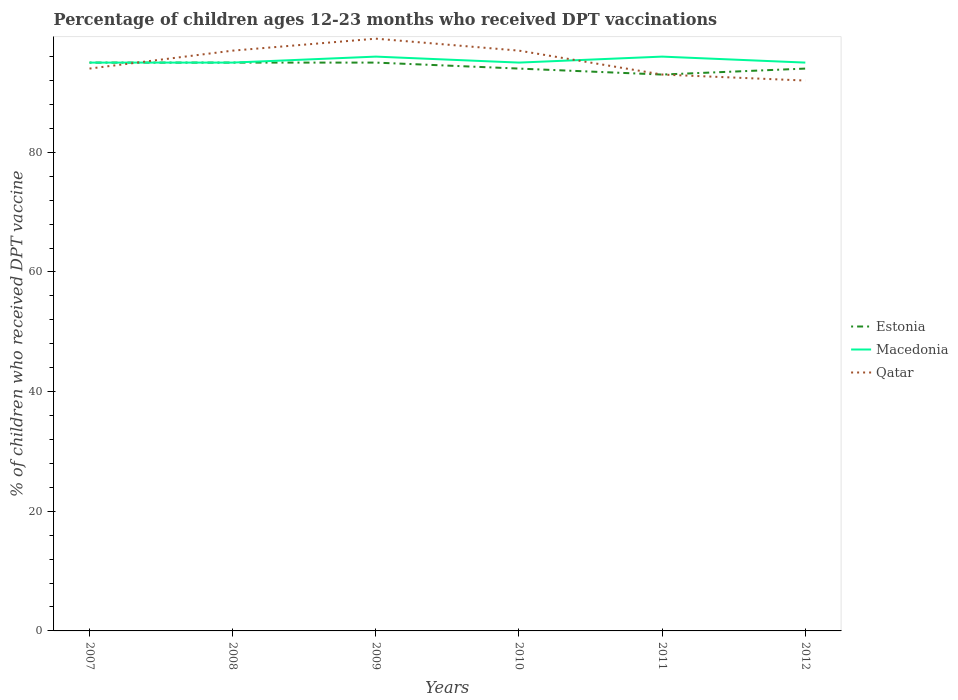How many different coloured lines are there?
Ensure brevity in your answer.  3. Does the line corresponding to Macedonia intersect with the line corresponding to Qatar?
Ensure brevity in your answer.  Yes. Is the number of lines equal to the number of legend labels?
Provide a short and direct response. Yes. Across all years, what is the maximum percentage of children who received DPT vaccination in Qatar?
Give a very brief answer. 92. What is the difference between the highest and the second highest percentage of children who received DPT vaccination in Estonia?
Give a very brief answer. 2. Is the percentage of children who received DPT vaccination in Estonia strictly greater than the percentage of children who received DPT vaccination in Qatar over the years?
Provide a succinct answer. No. What is the difference between two consecutive major ticks on the Y-axis?
Offer a terse response. 20. Are the values on the major ticks of Y-axis written in scientific E-notation?
Keep it short and to the point. No. Does the graph contain grids?
Keep it short and to the point. No. How many legend labels are there?
Your answer should be very brief. 3. How are the legend labels stacked?
Offer a very short reply. Vertical. What is the title of the graph?
Your response must be concise. Percentage of children ages 12-23 months who received DPT vaccinations. Does "Turks and Caicos Islands" appear as one of the legend labels in the graph?
Offer a terse response. No. What is the label or title of the Y-axis?
Ensure brevity in your answer.  % of children who received DPT vaccine. What is the % of children who received DPT vaccine in Macedonia in 2007?
Your answer should be very brief. 95. What is the % of children who received DPT vaccine of Qatar in 2007?
Your answer should be very brief. 94. What is the % of children who received DPT vaccine in Estonia in 2008?
Provide a short and direct response. 95. What is the % of children who received DPT vaccine in Qatar in 2008?
Your response must be concise. 97. What is the % of children who received DPT vaccine in Macedonia in 2009?
Offer a terse response. 96. What is the % of children who received DPT vaccine in Qatar in 2009?
Offer a terse response. 99. What is the % of children who received DPT vaccine in Estonia in 2010?
Your response must be concise. 94. What is the % of children who received DPT vaccine of Macedonia in 2010?
Ensure brevity in your answer.  95. What is the % of children who received DPT vaccine of Qatar in 2010?
Your response must be concise. 97. What is the % of children who received DPT vaccine of Estonia in 2011?
Ensure brevity in your answer.  93. What is the % of children who received DPT vaccine in Macedonia in 2011?
Offer a terse response. 96. What is the % of children who received DPT vaccine in Qatar in 2011?
Provide a short and direct response. 93. What is the % of children who received DPT vaccine of Estonia in 2012?
Ensure brevity in your answer.  94. What is the % of children who received DPT vaccine in Qatar in 2012?
Give a very brief answer. 92. Across all years, what is the maximum % of children who received DPT vaccine in Estonia?
Offer a very short reply. 95. Across all years, what is the maximum % of children who received DPT vaccine in Macedonia?
Your response must be concise. 96. Across all years, what is the minimum % of children who received DPT vaccine of Estonia?
Your answer should be compact. 93. Across all years, what is the minimum % of children who received DPT vaccine of Macedonia?
Keep it short and to the point. 95. Across all years, what is the minimum % of children who received DPT vaccine in Qatar?
Your response must be concise. 92. What is the total % of children who received DPT vaccine of Estonia in the graph?
Provide a succinct answer. 566. What is the total % of children who received DPT vaccine in Macedonia in the graph?
Make the answer very short. 572. What is the total % of children who received DPT vaccine in Qatar in the graph?
Offer a very short reply. 572. What is the difference between the % of children who received DPT vaccine of Estonia in 2007 and that in 2008?
Your answer should be compact. 0. What is the difference between the % of children who received DPT vaccine of Macedonia in 2007 and that in 2008?
Offer a very short reply. 0. What is the difference between the % of children who received DPT vaccine in Qatar in 2007 and that in 2008?
Your response must be concise. -3. What is the difference between the % of children who received DPT vaccine in Estonia in 2007 and that in 2009?
Keep it short and to the point. 0. What is the difference between the % of children who received DPT vaccine of Macedonia in 2007 and that in 2009?
Give a very brief answer. -1. What is the difference between the % of children who received DPT vaccine of Macedonia in 2007 and that in 2010?
Offer a very short reply. 0. What is the difference between the % of children who received DPT vaccine of Qatar in 2007 and that in 2010?
Offer a very short reply. -3. What is the difference between the % of children who received DPT vaccine in Macedonia in 2007 and that in 2011?
Provide a short and direct response. -1. What is the difference between the % of children who received DPT vaccine of Qatar in 2007 and that in 2012?
Keep it short and to the point. 2. What is the difference between the % of children who received DPT vaccine of Macedonia in 2008 and that in 2009?
Your response must be concise. -1. What is the difference between the % of children who received DPT vaccine of Qatar in 2008 and that in 2009?
Make the answer very short. -2. What is the difference between the % of children who received DPT vaccine in Macedonia in 2008 and that in 2010?
Provide a succinct answer. 0. What is the difference between the % of children who received DPT vaccine of Qatar in 2008 and that in 2011?
Your response must be concise. 4. What is the difference between the % of children who received DPT vaccine in Estonia in 2008 and that in 2012?
Ensure brevity in your answer.  1. What is the difference between the % of children who received DPT vaccine in Qatar in 2009 and that in 2011?
Give a very brief answer. 6. What is the difference between the % of children who received DPT vaccine in Macedonia in 2010 and that in 2011?
Your answer should be very brief. -1. What is the difference between the % of children who received DPT vaccine in Qatar in 2010 and that in 2011?
Offer a very short reply. 4. What is the difference between the % of children who received DPT vaccine in Estonia in 2010 and that in 2012?
Keep it short and to the point. 0. What is the difference between the % of children who received DPT vaccine in Macedonia in 2010 and that in 2012?
Ensure brevity in your answer.  0. What is the difference between the % of children who received DPT vaccine in Estonia in 2011 and that in 2012?
Provide a succinct answer. -1. What is the difference between the % of children who received DPT vaccine in Macedonia in 2011 and that in 2012?
Provide a short and direct response. 1. What is the difference between the % of children who received DPT vaccine of Estonia in 2007 and the % of children who received DPT vaccine of Macedonia in 2009?
Give a very brief answer. -1. What is the difference between the % of children who received DPT vaccine in Estonia in 2007 and the % of children who received DPT vaccine in Qatar in 2010?
Offer a very short reply. -2. What is the difference between the % of children who received DPT vaccine of Macedonia in 2007 and the % of children who received DPT vaccine of Qatar in 2010?
Keep it short and to the point. -2. What is the difference between the % of children who received DPT vaccine of Estonia in 2007 and the % of children who received DPT vaccine of Macedonia in 2012?
Your answer should be compact. 0. What is the difference between the % of children who received DPT vaccine in Estonia in 2007 and the % of children who received DPT vaccine in Qatar in 2012?
Your answer should be compact. 3. What is the difference between the % of children who received DPT vaccine in Macedonia in 2007 and the % of children who received DPT vaccine in Qatar in 2012?
Offer a very short reply. 3. What is the difference between the % of children who received DPT vaccine in Estonia in 2008 and the % of children who received DPT vaccine in Qatar in 2009?
Provide a succinct answer. -4. What is the difference between the % of children who received DPT vaccine of Estonia in 2008 and the % of children who received DPT vaccine of Macedonia in 2010?
Your answer should be very brief. 0. What is the difference between the % of children who received DPT vaccine in Estonia in 2008 and the % of children who received DPT vaccine in Qatar in 2010?
Offer a very short reply. -2. What is the difference between the % of children who received DPT vaccine of Macedonia in 2008 and the % of children who received DPT vaccine of Qatar in 2010?
Keep it short and to the point. -2. What is the difference between the % of children who received DPT vaccine in Estonia in 2008 and the % of children who received DPT vaccine in Macedonia in 2011?
Ensure brevity in your answer.  -1. What is the difference between the % of children who received DPT vaccine in Estonia in 2008 and the % of children who received DPT vaccine in Qatar in 2011?
Give a very brief answer. 2. What is the difference between the % of children who received DPT vaccine of Macedonia in 2008 and the % of children who received DPT vaccine of Qatar in 2011?
Your answer should be very brief. 2. What is the difference between the % of children who received DPT vaccine in Estonia in 2009 and the % of children who received DPT vaccine in Qatar in 2010?
Offer a terse response. -2. What is the difference between the % of children who received DPT vaccine of Estonia in 2009 and the % of children who received DPT vaccine of Macedonia in 2011?
Your answer should be very brief. -1. What is the difference between the % of children who received DPT vaccine of Estonia in 2009 and the % of children who received DPT vaccine of Qatar in 2011?
Give a very brief answer. 2. What is the difference between the % of children who received DPT vaccine of Macedonia in 2009 and the % of children who received DPT vaccine of Qatar in 2011?
Offer a very short reply. 3. What is the difference between the % of children who received DPT vaccine of Estonia in 2009 and the % of children who received DPT vaccine of Qatar in 2012?
Provide a succinct answer. 3. What is the difference between the % of children who received DPT vaccine of Estonia in 2010 and the % of children who received DPT vaccine of Macedonia in 2011?
Offer a very short reply. -2. What is the difference between the % of children who received DPT vaccine of Estonia in 2010 and the % of children who received DPT vaccine of Qatar in 2011?
Give a very brief answer. 1. What is the difference between the % of children who received DPT vaccine of Macedonia in 2010 and the % of children who received DPT vaccine of Qatar in 2011?
Provide a succinct answer. 2. What is the difference between the % of children who received DPT vaccine of Estonia in 2010 and the % of children who received DPT vaccine of Macedonia in 2012?
Your answer should be compact. -1. What is the difference between the % of children who received DPT vaccine in Estonia in 2010 and the % of children who received DPT vaccine in Qatar in 2012?
Your answer should be very brief. 2. What is the difference between the % of children who received DPT vaccine in Estonia in 2011 and the % of children who received DPT vaccine in Macedonia in 2012?
Give a very brief answer. -2. What is the average % of children who received DPT vaccine of Estonia per year?
Your response must be concise. 94.33. What is the average % of children who received DPT vaccine in Macedonia per year?
Offer a terse response. 95.33. What is the average % of children who received DPT vaccine of Qatar per year?
Your answer should be compact. 95.33. In the year 2007, what is the difference between the % of children who received DPT vaccine of Estonia and % of children who received DPT vaccine of Macedonia?
Offer a very short reply. 0. In the year 2007, what is the difference between the % of children who received DPT vaccine in Estonia and % of children who received DPT vaccine in Qatar?
Make the answer very short. 1. In the year 2007, what is the difference between the % of children who received DPT vaccine of Macedonia and % of children who received DPT vaccine of Qatar?
Provide a short and direct response. 1. In the year 2008, what is the difference between the % of children who received DPT vaccine of Estonia and % of children who received DPT vaccine of Macedonia?
Provide a short and direct response. 0. In the year 2008, what is the difference between the % of children who received DPT vaccine of Estonia and % of children who received DPT vaccine of Qatar?
Provide a short and direct response. -2. In the year 2008, what is the difference between the % of children who received DPT vaccine in Macedonia and % of children who received DPT vaccine in Qatar?
Offer a terse response. -2. In the year 2009, what is the difference between the % of children who received DPT vaccine in Estonia and % of children who received DPT vaccine in Macedonia?
Offer a very short reply. -1. In the year 2009, what is the difference between the % of children who received DPT vaccine of Macedonia and % of children who received DPT vaccine of Qatar?
Your answer should be compact. -3. In the year 2011, what is the difference between the % of children who received DPT vaccine in Estonia and % of children who received DPT vaccine in Qatar?
Offer a terse response. 0. In the year 2011, what is the difference between the % of children who received DPT vaccine in Macedonia and % of children who received DPT vaccine in Qatar?
Offer a terse response. 3. In the year 2012, what is the difference between the % of children who received DPT vaccine in Estonia and % of children who received DPT vaccine in Qatar?
Provide a succinct answer. 2. What is the ratio of the % of children who received DPT vaccine in Macedonia in 2007 to that in 2008?
Your answer should be very brief. 1. What is the ratio of the % of children who received DPT vaccine in Qatar in 2007 to that in 2008?
Keep it short and to the point. 0.97. What is the ratio of the % of children who received DPT vaccine of Estonia in 2007 to that in 2009?
Make the answer very short. 1. What is the ratio of the % of children who received DPT vaccine in Qatar in 2007 to that in 2009?
Ensure brevity in your answer.  0.95. What is the ratio of the % of children who received DPT vaccine in Estonia in 2007 to that in 2010?
Make the answer very short. 1.01. What is the ratio of the % of children who received DPT vaccine in Qatar in 2007 to that in 2010?
Ensure brevity in your answer.  0.97. What is the ratio of the % of children who received DPT vaccine in Estonia in 2007 to that in 2011?
Ensure brevity in your answer.  1.02. What is the ratio of the % of children who received DPT vaccine in Macedonia in 2007 to that in 2011?
Offer a terse response. 0.99. What is the ratio of the % of children who received DPT vaccine in Qatar in 2007 to that in 2011?
Offer a very short reply. 1.01. What is the ratio of the % of children who received DPT vaccine of Estonia in 2007 to that in 2012?
Ensure brevity in your answer.  1.01. What is the ratio of the % of children who received DPT vaccine of Qatar in 2007 to that in 2012?
Give a very brief answer. 1.02. What is the ratio of the % of children who received DPT vaccine of Estonia in 2008 to that in 2009?
Offer a very short reply. 1. What is the ratio of the % of children who received DPT vaccine in Macedonia in 2008 to that in 2009?
Keep it short and to the point. 0.99. What is the ratio of the % of children who received DPT vaccine in Qatar in 2008 to that in 2009?
Provide a short and direct response. 0.98. What is the ratio of the % of children who received DPT vaccine in Estonia in 2008 to that in 2010?
Offer a terse response. 1.01. What is the ratio of the % of children who received DPT vaccine of Estonia in 2008 to that in 2011?
Provide a short and direct response. 1.02. What is the ratio of the % of children who received DPT vaccine in Macedonia in 2008 to that in 2011?
Offer a very short reply. 0.99. What is the ratio of the % of children who received DPT vaccine in Qatar in 2008 to that in 2011?
Provide a short and direct response. 1.04. What is the ratio of the % of children who received DPT vaccine of Estonia in 2008 to that in 2012?
Give a very brief answer. 1.01. What is the ratio of the % of children who received DPT vaccine in Macedonia in 2008 to that in 2012?
Offer a very short reply. 1. What is the ratio of the % of children who received DPT vaccine of Qatar in 2008 to that in 2012?
Your response must be concise. 1.05. What is the ratio of the % of children who received DPT vaccine in Estonia in 2009 to that in 2010?
Give a very brief answer. 1.01. What is the ratio of the % of children who received DPT vaccine of Macedonia in 2009 to that in 2010?
Provide a short and direct response. 1.01. What is the ratio of the % of children who received DPT vaccine of Qatar in 2009 to that in 2010?
Offer a very short reply. 1.02. What is the ratio of the % of children who received DPT vaccine in Estonia in 2009 to that in 2011?
Your response must be concise. 1.02. What is the ratio of the % of children who received DPT vaccine in Qatar in 2009 to that in 2011?
Ensure brevity in your answer.  1.06. What is the ratio of the % of children who received DPT vaccine of Estonia in 2009 to that in 2012?
Make the answer very short. 1.01. What is the ratio of the % of children who received DPT vaccine in Macedonia in 2009 to that in 2012?
Your answer should be very brief. 1.01. What is the ratio of the % of children who received DPT vaccine of Qatar in 2009 to that in 2012?
Ensure brevity in your answer.  1.08. What is the ratio of the % of children who received DPT vaccine of Estonia in 2010 to that in 2011?
Offer a terse response. 1.01. What is the ratio of the % of children who received DPT vaccine of Qatar in 2010 to that in 2011?
Ensure brevity in your answer.  1.04. What is the ratio of the % of children who received DPT vaccine of Estonia in 2010 to that in 2012?
Ensure brevity in your answer.  1. What is the ratio of the % of children who received DPT vaccine in Macedonia in 2010 to that in 2012?
Give a very brief answer. 1. What is the ratio of the % of children who received DPT vaccine in Qatar in 2010 to that in 2012?
Give a very brief answer. 1.05. What is the ratio of the % of children who received DPT vaccine in Macedonia in 2011 to that in 2012?
Give a very brief answer. 1.01. What is the ratio of the % of children who received DPT vaccine of Qatar in 2011 to that in 2012?
Provide a succinct answer. 1.01. What is the difference between the highest and the second highest % of children who received DPT vaccine of Estonia?
Make the answer very short. 0. What is the difference between the highest and the second highest % of children who received DPT vaccine of Macedonia?
Your answer should be very brief. 0. What is the difference between the highest and the second highest % of children who received DPT vaccine of Qatar?
Your answer should be compact. 2. What is the difference between the highest and the lowest % of children who received DPT vaccine in Macedonia?
Offer a terse response. 1. 